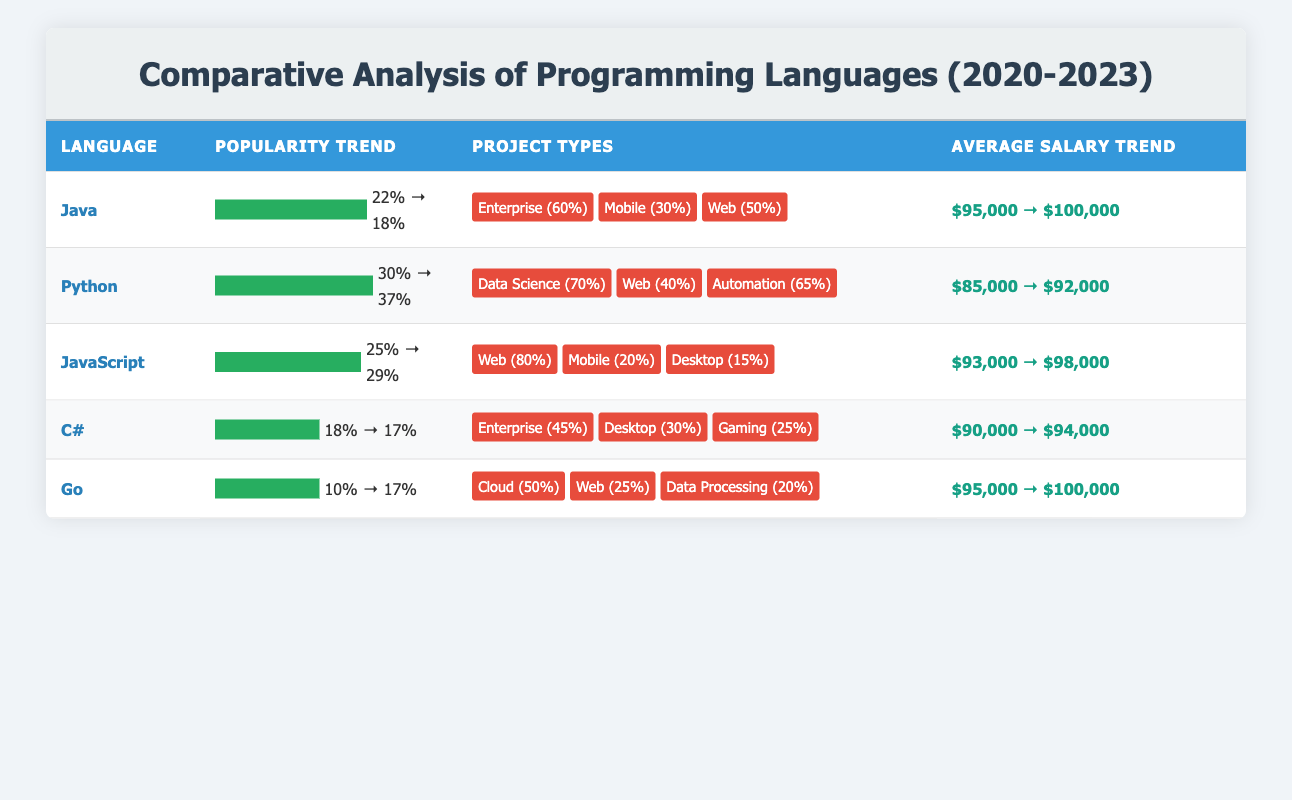What was the highest average salary among the programming languages in 2023? In 2023, the average salaries for the programming languages are as follows: Java at $100,000, Python at $92,000, JavaScript at $98,000, C# at $94,000, and Go at $100,000. Comparing these values, both Java and Go have the highest average salary at $100,000.
Answer: $100,000 Which programming language experienced the highest increase in popularity from 2020 to 2023? The popularity changes from 2020 to 2023 for each language are: Java from 22% to 18%, Python from 30% to 37%, JavaScript from 25% to 29%, C# from 18% to 17%, and Go from 10% to 17%. The increase is only seen in Python (7%) and Go (7%). However, Python has the relative highest percentage increase, going from 30% to 37%.
Answer: Python Did C# see an increase or decrease in average salary from 2020 to 2023? C# had an average salary of $90,000 in 2020 and $94,000 in 2023. To determine if it saw an increase or decrease, we check these values; since $94,000 is greater than $90,000, C# experienced an increase in average salary.
Answer: Increase What is the total percentage of projects focused on data science across the languages? The only language that focuses on data science is Python, which dedicates 70% of its projects to that field. The other languages do not mention data science in their project types, contributing 0% to this total. Thus, the sum is 70% for Python.
Answer: 70% Which programming language had the lowest popularity in 2020? The popularity percentages in 2020 were: Java at 22%, Python at 30%, JavaScript at 25%, C# at 18%, and Go at 10%. The lowest value from these figures is Go at 10%.
Answer: Go What was the average average salary for the top three programming languages by 2023 popularity? The top three languages by popularity in 2023 are: Python (37%), JavaScript (29%), and Java (18%). Their average salaries are $92,000 for Python, $98,000 for JavaScript, and $100,000 for Java. The total salary is $92,000 + $98,000 + $100,000 = $290,000. To find the average, divide this total by 3, so $290,000 / 3 = approximately $96,667.
Answer: Approximately $96,667 Did JavaScript or C# have a higher percentage of web projects? JavaScript has 80% of its projects focused on web, while C# has only 0% specified for web projects. Comparing these two values indicates that JavaScript has a higher percentage of web projects than C#.
Answer: JavaScript Which language has the most diverse project types, and how many types does it have? Reviewing the project types: Java includes three (enterprise, mobile, web), Python includes three (data science, web, automation), JavaScript has three (web, mobile, desktop), C# includes three (enterprise, desktop, gaming), and Go includes three (cloud, web, data processing). Each language has three project types. However, considering the diversity, they are all equal.
Answer: Equal diversity (three types each) 